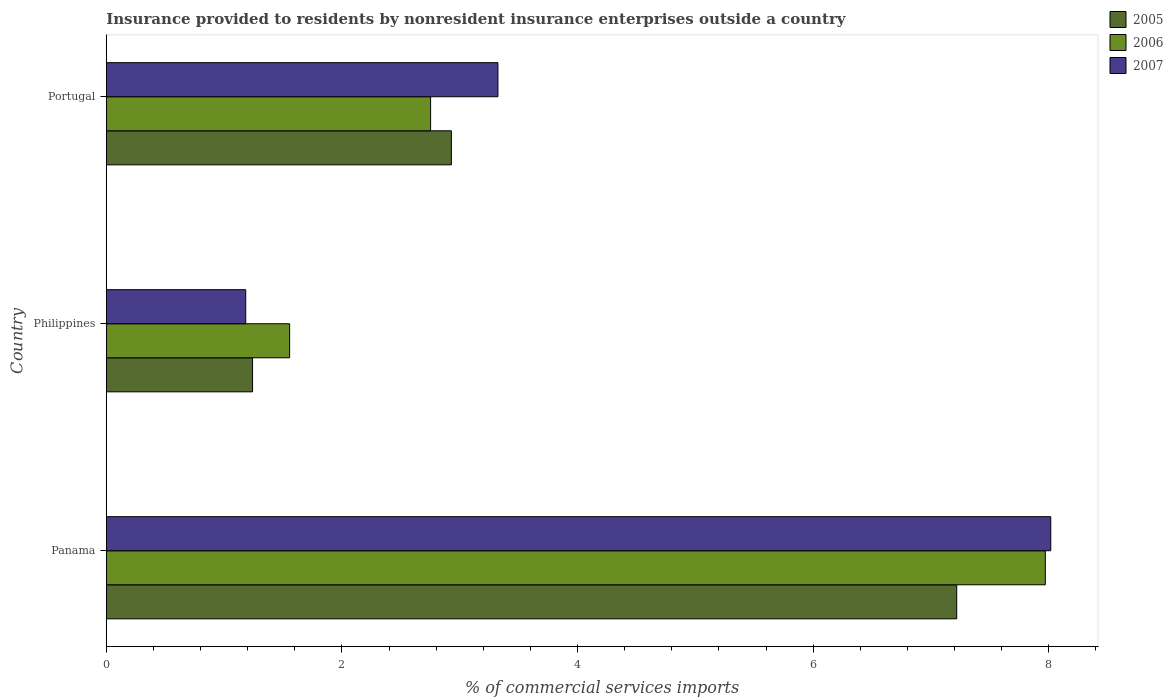How many different coloured bars are there?
Your answer should be very brief. 3. How many groups of bars are there?
Your answer should be very brief. 3. Are the number of bars on each tick of the Y-axis equal?
Offer a very short reply. Yes. How many bars are there on the 1st tick from the bottom?
Make the answer very short. 3. What is the label of the 2nd group of bars from the top?
Give a very brief answer. Philippines. In how many cases, is the number of bars for a given country not equal to the number of legend labels?
Your answer should be compact. 0. What is the Insurance provided to residents in 2006 in Philippines?
Ensure brevity in your answer.  1.56. Across all countries, what is the maximum Insurance provided to residents in 2007?
Give a very brief answer. 8.02. Across all countries, what is the minimum Insurance provided to residents in 2007?
Offer a very short reply. 1.18. In which country was the Insurance provided to residents in 2006 maximum?
Provide a short and direct response. Panama. What is the total Insurance provided to residents in 2007 in the graph?
Provide a short and direct response. 12.52. What is the difference between the Insurance provided to residents in 2006 in Panama and that in Philippines?
Give a very brief answer. 6.41. What is the difference between the Insurance provided to residents in 2005 in Panama and the Insurance provided to residents in 2006 in Portugal?
Give a very brief answer. 4.47. What is the average Insurance provided to residents in 2005 per country?
Your response must be concise. 3.8. What is the difference between the Insurance provided to residents in 2005 and Insurance provided to residents in 2006 in Portugal?
Ensure brevity in your answer.  0.18. In how many countries, is the Insurance provided to residents in 2007 greater than 7.6 %?
Offer a very short reply. 1. What is the ratio of the Insurance provided to residents in 2005 in Philippines to that in Portugal?
Provide a short and direct response. 0.42. Is the Insurance provided to residents in 2007 in Panama less than that in Philippines?
Your answer should be very brief. No. Is the difference between the Insurance provided to residents in 2005 in Panama and Philippines greater than the difference between the Insurance provided to residents in 2006 in Panama and Philippines?
Your answer should be very brief. No. What is the difference between the highest and the second highest Insurance provided to residents in 2006?
Your answer should be compact. 5.22. What is the difference between the highest and the lowest Insurance provided to residents in 2007?
Make the answer very short. 6.83. What does the 1st bar from the top in Philippines represents?
Give a very brief answer. 2007. Is it the case that in every country, the sum of the Insurance provided to residents in 2007 and Insurance provided to residents in 2005 is greater than the Insurance provided to residents in 2006?
Offer a terse response. Yes. Are all the bars in the graph horizontal?
Provide a short and direct response. Yes. How many countries are there in the graph?
Offer a terse response. 3. What is the difference between two consecutive major ticks on the X-axis?
Give a very brief answer. 2. Are the values on the major ticks of X-axis written in scientific E-notation?
Your answer should be very brief. No. Does the graph contain any zero values?
Your answer should be very brief. No. Where does the legend appear in the graph?
Your answer should be very brief. Top right. How many legend labels are there?
Provide a succinct answer. 3. How are the legend labels stacked?
Give a very brief answer. Vertical. What is the title of the graph?
Make the answer very short. Insurance provided to residents by nonresident insurance enterprises outside a country. What is the label or title of the X-axis?
Provide a short and direct response. % of commercial services imports. What is the % of commercial services imports of 2005 in Panama?
Ensure brevity in your answer.  7.22. What is the % of commercial services imports of 2006 in Panama?
Provide a short and direct response. 7.97. What is the % of commercial services imports in 2007 in Panama?
Give a very brief answer. 8.02. What is the % of commercial services imports of 2005 in Philippines?
Give a very brief answer. 1.24. What is the % of commercial services imports of 2006 in Philippines?
Offer a very short reply. 1.56. What is the % of commercial services imports of 2007 in Philippines?
Provide a succinct answer. 1.18. What is the % of commercial services imports in 2005 in Portugal?
Offer a terse response. 2.93. What is the % of commercial services imports in 2006 in Portugal?
Keep it short and to the point. 2.75. What is the % of commercial services imports of 2007 in Portugal?
Your answer should be very brief. 3.32. Across all countries, what is the maximum % of commercial services imports of 2005?
Offer a very short reply. 7.22. Across all countries, what is the maximum % of commercial services imports in 2006?
Ensure brevity in your answer.  7.97. Across all countries, what is the maximum % of commercial services imports of 2007?
Provide a succinct answer. 8.02. Across all countries, what is the minimum % of commercial services imports of 2005?
Your answer should be very brief. 1.24. Across all countries, what is the minimum % of commercial services imports of 2006?
Ensure brevity in your answer.  1.56. Across all countries, what is the minimum % of commercial services imports of 2007?
Provide a succinct answer. 1.18. What is the total % of commercial services imports of 2005 in the graph?
Ensure brevity in your answer.  11.39. What is the total % of commercial services imports of 2006 in the graph?
Your answer should be very brief. 12.28. What is the total % of commercial services imports in 2007 in the graph?
Offer a very short reply. 12.52. What is the difference between the % of commercial services imports in 2005 in Panama and that in Philippines?
Your response must be concise. 5.98. What is the difference between the % of commercial services imports in 2006 in Panama and that in Philippines?
Give a very brief answer. 6.41. What is the difference between the % of commercial services imports of 2007 in Panama and that in Philippines?
Make the answer very short. 6.83. What is the difference between the % of commercial services imports of 2005 in Panama and that in Portugal?
Keep it short and to the point. 4.29. What is the difference between the % of commercial services imports of 2006 in Panama and that in Portugal?
Give a very brief answer. 5.22. What is the difference between the % of commercial services imports of 2007 in Panama and that in Portugal?
Provide a succinct answer. 4.69. What is the difference between the % of commercial services imports of 2005 in Philippines and that in Portugal?
Provide a short and direct response. -1.69. What is the difference between the % of commercial services imports in 2006 in Philippines and that in Portugal?
Offer a very short reply. -1.2. What is the difference between the % of commercial services imports of 2007 in Philippines and that in Portugal?
Ensure brevity in your answer.  -2.14. What is the difference between the % of commercial services imports of 2005 in Panama and the % of commercial services imports of 2006 in Philippines?
Keep it short and to the point. 5.66. What is the difference between the % of commercial services imports in 2005 in Panama and the % of commercial services imports in 2007 in Philippines?
Provide a short and direct response. 6.04. What is the difference between the % of commercial services imports in 2006 in Panama and the % of commercial services imports in 2007 in Philippines?
Keep it short and to the point. 6.79. What is the difference between the % of commercial services imports in 2005 in Panama and the % of commercial services imports in 2006 in Portugal?
Keep it short and to the point. 4.47. What is the difference between the % of commercial services imports in 2005 in Panama and the % of commercial services imports in 2007 in Portugal?
Give a very brief answer. 3.89. What is the difference between the % of commercial services imports in 2006 in Panama and the % of commercial services imports in 2007 in Portugal?
Your response must be concise. 4.65. What is the difference between the % of commercial services imports in 2005 in Philippines and the % of commercial services imports in 2006 in Portugal?
Your answer should be very brief. -1.51. What is the difference between the % of commercial services imports in 2005 in Philippines and the % of commercial services imports in 2007 in Portugal?
Offer a very short reply. -2.08. What is the difference between the % of commercial services imports of 2006 in Philippines and the % of commercial services imports of 2007 in Portugal?
Offer a terse response. -1.77. What is the average % of commercial services imports in 2005 per country?
Your answer should be compact. 3.8. What is the average % of commercial services imports in 2006 per country?
Your response must be concise. 4.09. What is the average % of commercial services imports of 2007 per country?
Give a very brief answer. 4.17. What is the difference between the % of commercial services imports of 2005 and % of commercial services imports of 2006 in Panama?
Make the answer very short. -0.75. What is the difference between the % of commercial services imports in 2005 and % of commercial services imports in 2007 in Panama?
Keep it short and to the point. -0.8. What is the difference between the % of commercial services imports of 2006 and % of commercial services imports of 2007 in Panama?
Offer a very short reply. -0.05. What is the difference between the % of commercial services imports of 2005 and % of commercial services imports of 2006 in Philippines?
Ensure brevity in your answer.  -0.31. What is the difference between the % of commercial services imports of 2005 and % of commercial services imports of 2007 in Philippines?
Give a very brief answer. 0.06. What is the difference between the % of commercial services imports in 2006 and % of commercial services imports in 2007 in Philippines?
Your response must be concise. 0.37. What is the difference between the % of commercial services imports of 2005 and % of commercial services imports of 2006 in Portugal?
Provide a succinct answer. 0.18. What is the difference between the % of commercial services imports in 2005 and % of commercial services imports in 2007 in Portugal?
Provide a short and direct response. -0.4. What is the difference between the % of commercial services imports of 2006 and % of commercial services imports of 2007 in Portugal?
Your answer should be very brief. -0.57. What is the ratio of the % of commercial services imports in 2005 in Panama to that in Philippines?
Provide a succinct answer. 5.82. What is the ratio of the % of commercial services imports in 2006 in Panama to that in Philippines?
Your answer should be very brief. 5.12. What is the ratio of the % of commercial services imports of 2007 in Panama to that in Philippines?
Offer a very short reply. 6.78. What is the ratio of the % of commercial services imports of 2005 in Panama to that in Portugal?
Offer a terse response. 2.46. What is the ratio of the % of commercial services imports in 2006 in Panama to that in Portugal?
Your response must be concise. 2.9. What is the ratio of the % of commercial services imports of 2007 in Panama to that in Portugal?
Make the answer very short. 2.41. What is the ratio of the % of commercial services imports of 2005 in Philippines to that in Portugal?
Offer a terse response. 0.42. What is the ratio of the % of commercial services imports of 2006 in Philippines to that in Portugal?
Provide a short and direct response. 0.57. What is the ratio of the % of commercial services imports of 2007 in Philippines to that in Portugal?
Give a very brief answer. 0.36. What is the difference between the highest and the second highest % of commercial services imports of 2005?
Offer a terse response. 4.29. What is the difference between the highest and the second highest % of commercial services imports of 2006?
Keep it short and to the point. 5.22. What is the difference between the highest and the second highest % of commercial services imports in 2007?
Give a very brief answer. 4.69. What is the difference between the highest and the lowest % of commercial services imports of 2005?
Make the answer very short. 5.98. What is the difference between the highest and the lowest % of commercial services imports in 2006?
Make the answer very short. 6.41. What is the difference between the highest and the lowest % of commercial services imports in 2007?
Keep it short and to the point. 6.83. 